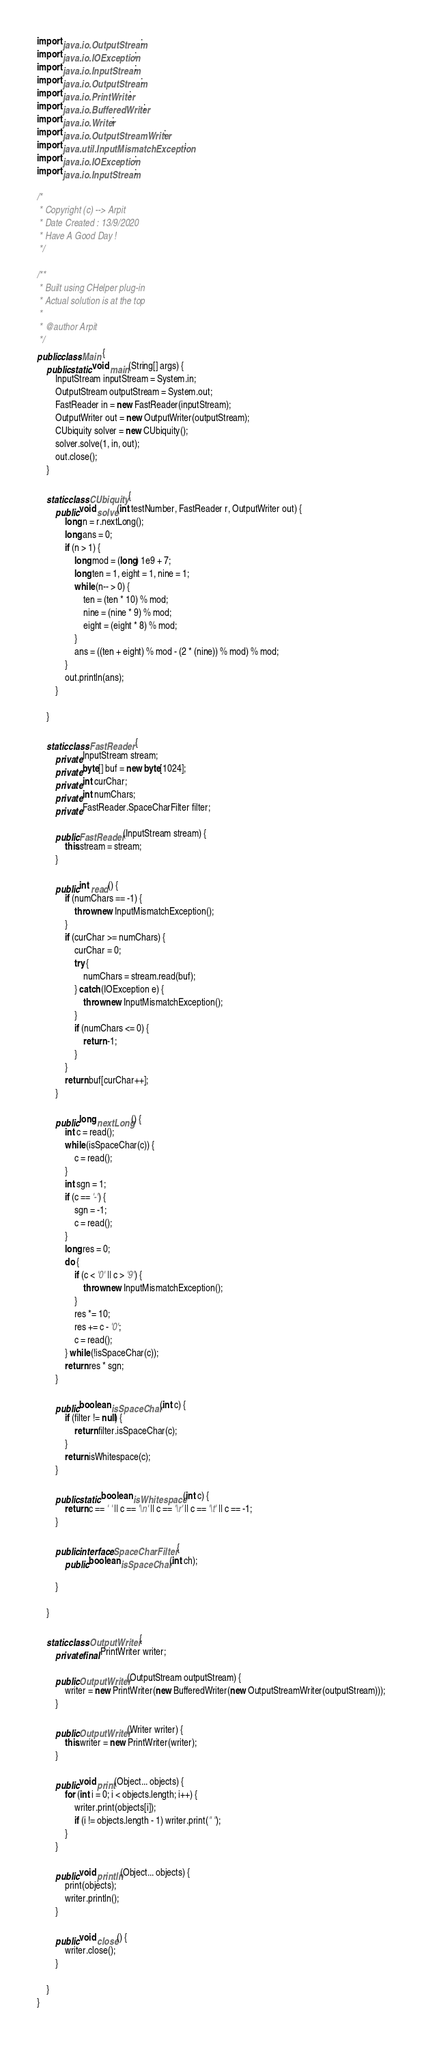<code> <loc_0><loc_0><loc_500><loc_500><_Java_>import java.io.OutputStream;
import java.io.IOException;
import java.io.InputStream;
import java.io.OutputStream;
import java.io.PrintWriter;
import java.io.BufferedWriter;
import java.io.Writer;
import java.io.OutputStreamWriter;
import java.util.InputMismatchException;
import java.io.IOException;
import java.io.InputStream;

/*
 * Copyright (c) --> Arpit
 * Date Created : 13/9/2020
 * Have A Good Day !
 */

/**
 * Built using CHelper plug-in
 * Actual solution is at the top
 *
 * @author Arpit
 */
public class Main {
    public static void main(String[] args) {
        InputStream inputStream = System.in;
        OutputStream outputStream = System.out;
        FastReader in = new FastReader(inputStream);
        OutputWriter out = new OutputWriter(outputStream);
        CUbiquity solver = new CUbiquity();
        solver.solve(1, in, out);
        out.close();
    }
    
    static class CUbiquity {
        public void solve(int testNumber, FastReader r, OutputWriter out) {
            long n = r.nextLong();
            long ans = 0;
            if (n > 1) {
                long mod = (long) 1e9 + 7;
                long ten = 1, eight = 1, nine = 1;
                while (n-- > 0) {
                    ten = (ten * 10) % mod;
                    nine = (nine * 9) % mod;
                    eight = (eight * 8) % mod;
                }
                ans = ((ten + eight) % mod - (2 * (nine)) % mod) % mod;
            }
            out.println(ans);
        }
        
    }
    
    static class FastReader {
        private InputStream stream;
        private byte[] buf = new byte[1024];
        private int curChar;
        private int numChars;
        private FastReader.SpaceCharFilter filter;
        
        public FastReader(InputStream stream) {
            this.stream = stream;
        }
        
        public int read() {
            if (numChars == -1) {
                throw new InputMismatchException();
            }
            if (curChar >= numChars) {
                curChar = 0;
                try {
                    numChars = stream.read(buf);
                } catch (IOException e) {
                    throw new InputMismatchException();
                }
                if (numChars <= 0) {
                    return -1;
                }
            }
            return buf[curChar++];
        }
        
        public long nextLong() {
            int c = read();
            while (isSpaceChar(c)) {
                c = read();
            }
            int sgn = 1;
            if (c == '-') {
                sgn = -1;
                c = read();
            }
            long res = 0;
            do {
                if (c < '0' || c > '9') {
                    throw new InputMismatchException();
                }
                res *= 10;
                res += c - '0';
                c = read();
            } while (!isSpaceChar(c));
            return res * sgn;
        }
        
        public boolean isSpaceChar(int c) {
            if (filter != null) {
                return filter.isSpaceChar(c);
            }
            return isWhitespace(c);
        }
        
        public static boolean isWhitespace(int c) {
            return c == ' ' || c == '\n' || c == '\r' || c == '\t' || c == -1;
        }
        
        public interface SpaceCharFilter {
            public boolean isSpaceChar(int ch);
            
        }
        
    }
    
    static class OutputWriter {
        private final PrintWriter writer;
        
        public OutputWriter(OutputStream outputStream) {
            writer = new PrintWriter(new BufferedWriter(new OutputStreamWriter(outputStream)));
        }
        
        public OutputWriter(Writer writer) {
            this.writer = new PrintWriter(writer);
        }
        
        public void print(Object... objects) {
            for (int i = 0; i < objects.length; i++) {
                writer.print(objects[i]);
                if (i != objects.length - 1) writer.print(" ");
            }
        }
        
        public void println(Object... objects) {
            print(objects);
            writer.println();
        }
        
        public void close() {
            writer.close();
        }
        
    }
}

</code> 